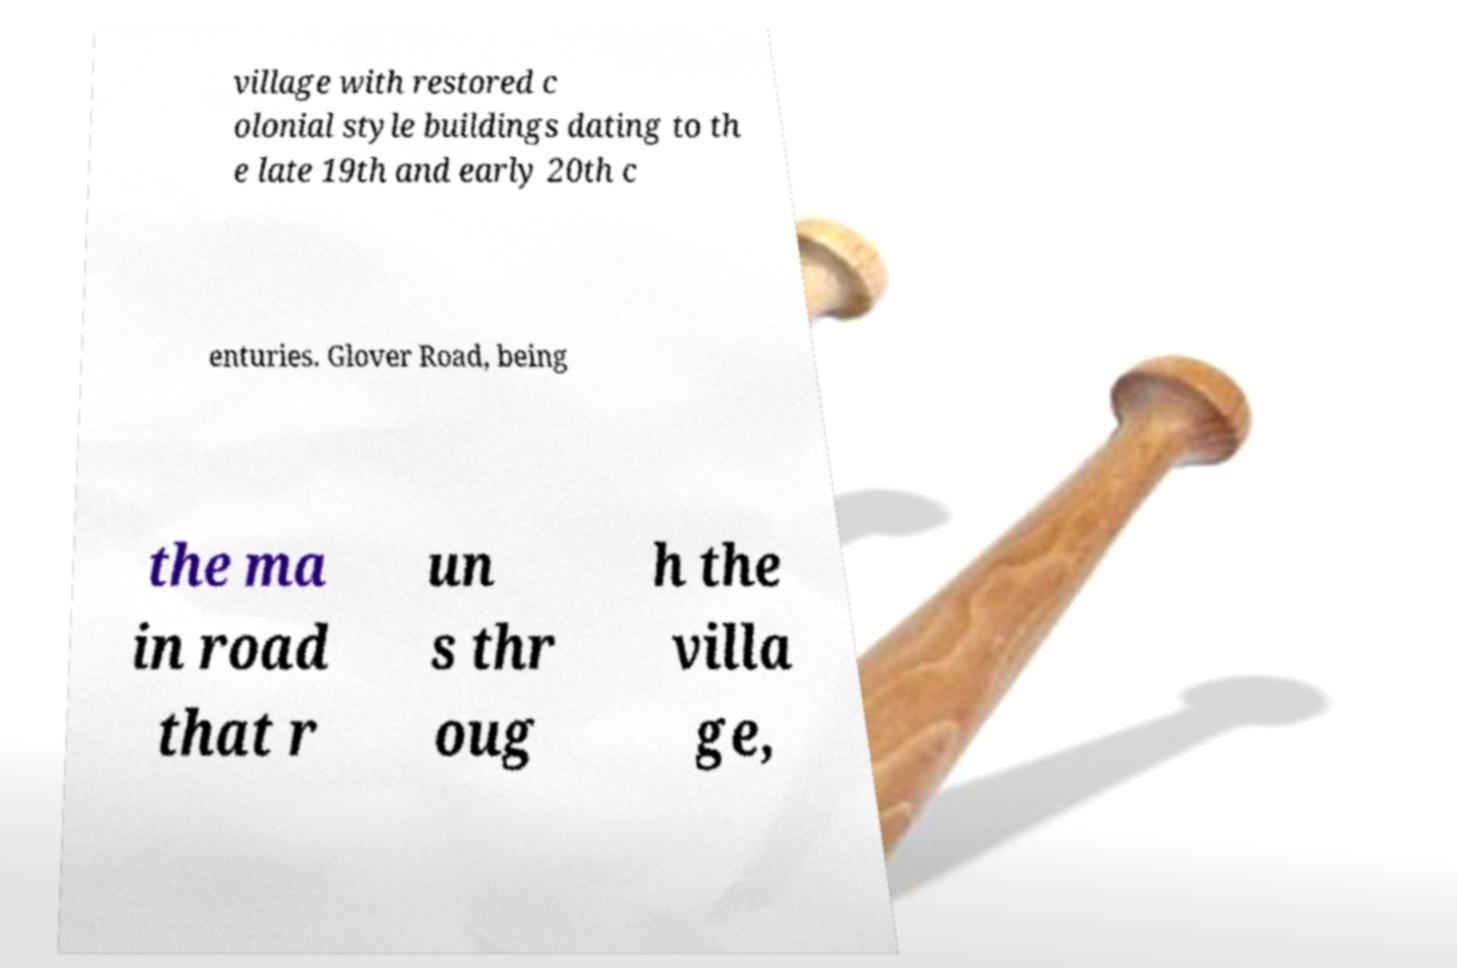I need the written content from this picture converted into text. Can you do that? village with restored c olonial style buildings dating to th e late 19th and early 20th c enturies. Glover Road, being the ma in road that r un s thr oug h the villa ge, 